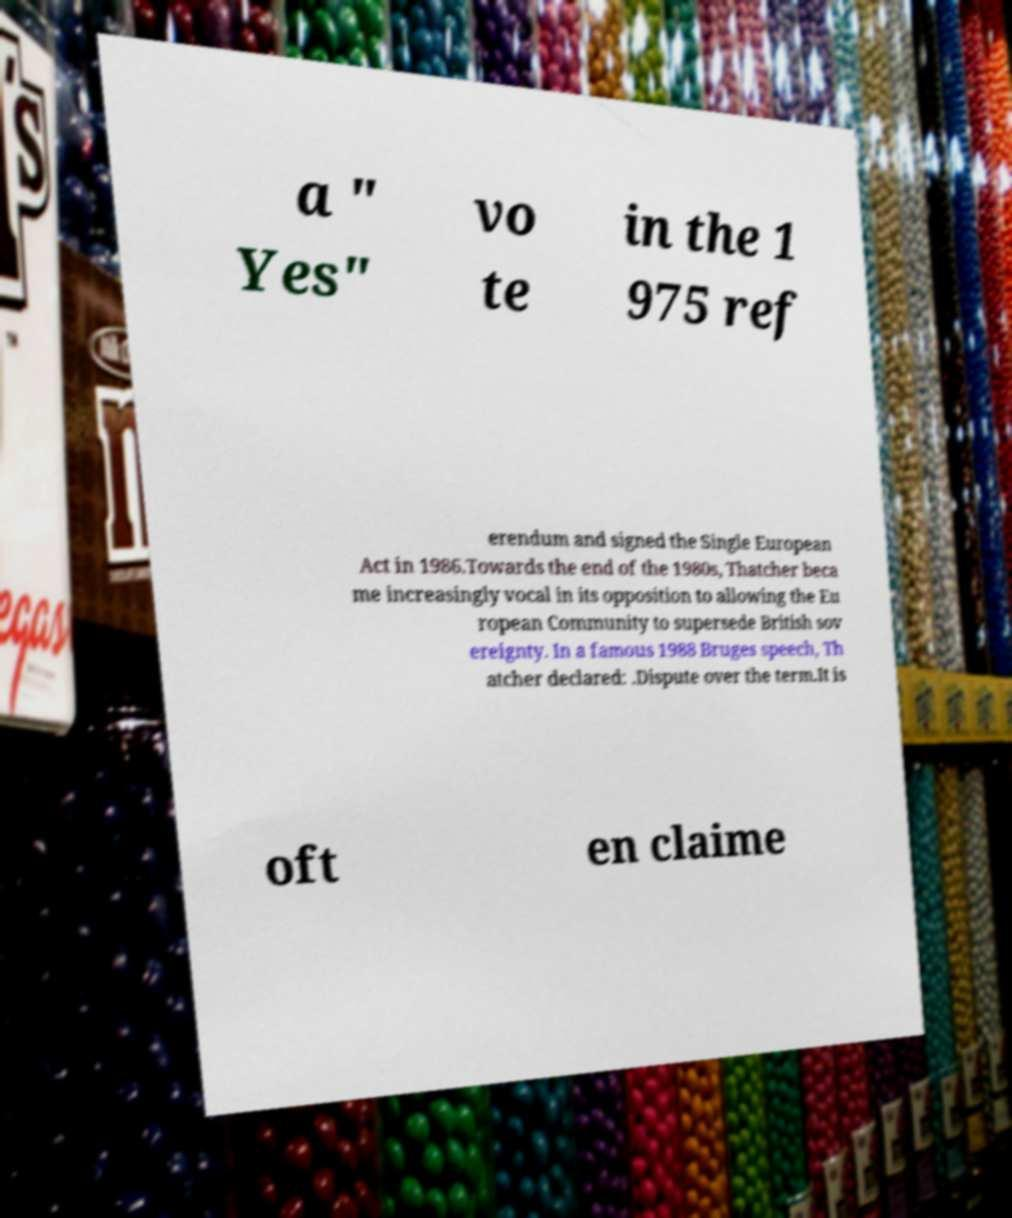There's text embedded in this image that I need extracted. Can you transcribe it verbatim? a " Yes" vo te in the 1 975 ref erendum and signed the Single European Act in 1986.Towards the end of the 1980s, Thatcher beca me increasingly vocal in its opposition to allowing the Eu ropean Community to supersede British sov ereignty. In a famous 1988 Bruges speech, Th atcher declared: .Dispute over the term.It is oft en claime 